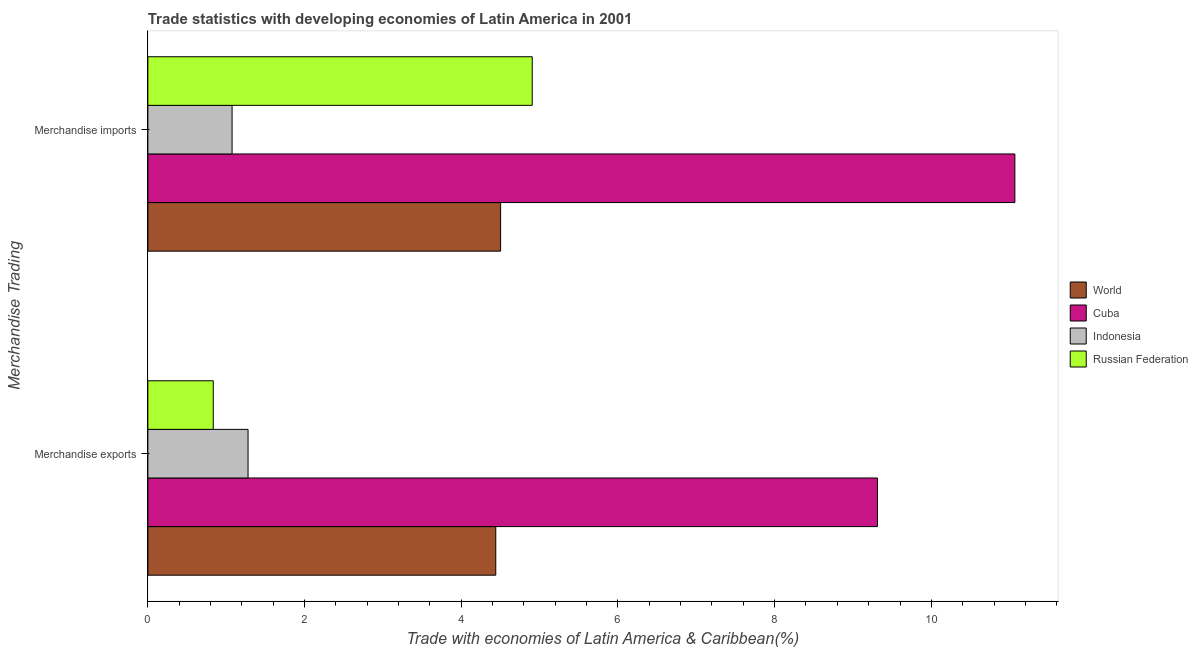How many different coloured bars are there?
Give a very brief answer. 4. How many groups of bars are there?
Offer a very short reply. 2. Are the number of bars on each tick of the Y-axis equal?
Keep it short and to the point. Yes. How many bars are there on the 2nd tick from the top?
Offer a very short reply. 4. What is the label of the 1st group of bars from the top?
Keep it short and to the point. Merchandise imports. What is the merchandise imports in Indonesia?
Keep it short and to the point. 1.07. Across all countries, what is the maximum merchandise exports?
Provide a short and direct response. 9.31. Across all countries, what is the minimum merchandise imports?
Provide a succinct answer. 1.07. In which country was the merchandise imports maximum?
Your answer should be compact. Cuba. In which country was the merchandise exports minimum?
Keep it short and to the point. Russian Federation. What is the total merchandise exports in the graph?
Provide a short and direct response. 15.87. What is the difference between the merchandise exports in World and that in Russian Federation?
Make the answer very short. 3.61. What is the difference between the merchandise exports in World and the merchandise imports in Indonesia?
Your answer should be very brief. 3.37. What is the average merchandise imports per country?
Ensure brevity in your answer.  5.39. What is the difference between the merchandise exports and merchandise imports in Cuba?
Give a very brief answer. -1.75. What is the ratio of the merchandise imports in Russian Federation to that in Cuba?
Your answer should be very brief. 0.44. In how many countries, is the merchandise imports greater than the average merchandise imports taken over all countries?
Keep it short and to the point. 1. What does the 2nd bar from the bottom in Merchandise exports represents?
Your answer should be very brief. Cuba. How many bars are there?
Provide a succinct answer. 8. How many countries are there in the graph?
Make the answer very short. 4. Are the values on the major ticks of X-axis written in scientific E-notation?
Offer a very short reply. No. Does the graph contain grids?
Provide a short and direct response. No. How many legend labels are there?
Make the answer very short. 4. What is the title of the graph?
Provide a succinct answer. Trade statistics with developing economies of Latin America in 2001. Does "Belize" appear as one of the legend labels in the graph?
Provide a succinct answer. No. What is the label or title of the X-axis?
Offer a very short reply. Trade with economies of Latin America & Caribbean(%). What is the label or title of the Y-axis?
Offer a very short reply. Merchandise Trading. What is the Trade with economies of Latin America & Caribbean(%) of World in Merchandise exports?
Keep it short and to the point. 4.44. What is the Trade with economies of Latin America & Caribbean(%) of Cuba in Merchandise exports?
Offer a terse response. 9.31. What is the Trade with economies of Latin America & Caribbean(%) in Indonesia in Merchandise exports?
Your answer should be very brief. 1.28. What is the Trade with economies of Latin America & Caribbean(%) of Russian Federation in Merchandise exports?
Keep it short and to the point. 0.83. What is the Trade with economies of Latin America & Caribbean(%) in World in Merchandise imports?
Provide a succinct answer. 4.5. What is the Trade with economies of Latin America & Caribbean(%) in Cuba in Merchandise imports?
Your response must be concise. 11.07. What is the Trade with economies of Latin America & Caribbean(%) of Indonesia in Merchandise imports?
Offer a terse response. 1.07. What is the Trade with economies of Latin America & Caribbean(%) of Russian Federation in Merchandise imports?
Make the answer very short. 4.91. Across all Merchandise Trading, what is the maximum Trade with economies of Latin America & Caribbean(%) of World?
Make the answer very short. 4.5. Across all Merchandise Trading, what is the maximum Trade with economies of Latin America & Caribbean(%) in Cuba?
Give a very brief answer. 11.07. Across all Merchandise Trading, what is the maximum Trade with economies of Latin America & Caribbean(%) of Indonesia?
Keep it short and to the point. 1.28. Across all Merchandise Trading, what is the maximum Trade with economies of Latin America & Caribbean(%) of Russian Federation?
Offer a terse response. 4.91. Across all Merchandise Trading, what is the minimum Trade with economies of Latin America & Caribbean(%) of World?
Provide a succinct answer. 4.44. Across all Merchandise Trading, what is the minimum Trade with economies of Latin America & Caribbean(%) of Cuba?
Offer a very short reply. 9.31. Across all Merchandise Trading, what is the minimum Trade with economies of Latin America & Caribbean(%) in Indonesia?
Keep it short and to the point. 1.07. Across all Merchandise Trading, what is the minimum Trade with economies of Latin America & Caribbean(%) in Russian Federation?
Offer a very short reply. 0.83. What is the total Trade with economies of Latin America & Caribbean(%) of World in the graph?
Offer a very short reply. 8.94. What is the total Trade with economies of Latin America & Caribbean(%) in Cuba in the graph?
Provide a succinct answer. 20.38. What is the total Trade with economies of Latin America & Caribbean(%) of Indonesia in the graph?
Your answer should be very brief. 2.35. What is the total Trade with economies of Latin America & Caribbean(%) of Russian Federation in the graph?
Provide a succinct answer. 5.74. What is the difference between the Trade with economies of Latin America & Caribbean(%) in World in Merchandise exports and that in Merchandise imports?
Your answer should be very brief. -0.06. What is the difference between the Trade with economies of Latin America & Caribbean(%) of Cuba in Merchandise exports and that in Merchandise imports?
Give a very brief answer. -1.75. What is the difference between the Trade with economies of Latin America & Caribbean(%) in Indonesia in Merchandise exports and that in Merchandise imports?
Your answer should be compact. 0.2. What is the difference between the Trade with economies of Latin America & Caribbean(%) in Russian Federation in Merchandise exports and that in Merchandise imports?
Provide a succinct answer. -4.07. What is the difference between the Trade with economies of Latin America & Caribbean(%) of World in Merchandise exports and the Trade with economies of Latin America & Caribbean(%) of Cuba in Merchandise imports?
Offer a very short reply. -6.63. What is the difference between the Trade with economies of Latin America & Caribbean(%) in World in Merchandise exports and the Trade with economies of Latin America & Caribbean(%) in Indonesia in Merchandise imports?
Provide a short and direct response. 3.37. What is the difference between the Trade with economies of Latin America & Caribbean(%) of World in Merchandise exports and the Trade with economies of Latin America & Caribbean(%) of Russian Federation in Merchandise imports?
Provide a succinct answer. -0.47. What is the difference between the Trade with economies of Latin America & Caribbean(%) of Cuba in Merchandise exports and the Trade with economies of Latin America & Caribbean(%) of Indonesia in Merchandise imports?
Your response must be concise. 8.24. What is the difference between the Trade with economies of Latin America & Caribbean(%) in Cuba in Merchandise exports and the Trade with economies of Latin America & Caribbean(%) in Russian Federation in Merchandise imports?
Offer a very short reply. 4.41. What is the difference between the Trade with economies of Latin America & Caribbean(%) in Indonesia in Merchandise exports and the Trade with economies of Latin America & Caribbean(%) in Russian Federation in Merchandise imports?
Keep it short and to the point. -3.63. What is the average Trade with economies of Latin America & Caribbean(%) in World per Merchandise Trading?
Provide a succinct answer. 4.47. What is the average Trade with economies of Latin America & Caribbean(%) in Cuba per Merchandise Trading?
Your answer should be compact. 10.19. What is the average Trade with economies of Latin America & Caribbean(%) in Indonesia per Merchandise Trading?
Your response must be concise. 1.18. What is the average Trade with economies of Latin America & Caribbean(%) in Russian Federation per Merchandise Trading?
Offer a very short reply. 2.87. What is the difference between the Trade with economies of Latin America & Caribbean(%) of World and Trade with economies of Latin America & Caribbean(%) of Cuba in Merchandise exports?
Your response must be concise. -4.87. What is the difference between the Trade with economies of Latin America & Caribbean(%) of World and Trade with economies of Latin America & Caribbean(%) of Indonesia in Merchandise exports?
Your response must be concise. 3.16. What is the difference between the Trade with economies of Latin America & Caribbean(%) of World and Trade with economies of Latin America & Caribbean(%) of Russian Federation in Merchandise exports?
Provide a short and direct response. 3.61. What is the difference between the Trade with economies of Latin America & Caribbean(%) in Cuba and Trade with economies of Latin America & Caribbean(%) in Indonesia in Merchandise exports?
Your answer should be compact. 8.03. What is the difference between the Trade with economies of Latin America & Caribbean(%) of Cuba and Trade with economies of Latin America & Caribbean(%) of Russian Federation in Merchandise exports?
Ensure brevity in your answer.  8.48. What is the difference between the Trade with economies of Latin America & Caribbean(%) of Indonesia and Trade with economies of Latin America & Caribbean(%) of Russian Federation in Merchandise exports?
Offer a terse response. 0.44. What is the difference between the Trade with economies of Latin America & Caribbean(%) of World and Trade with economies of Latin America & Caribbean(%) of Cuba in Merchandise imports?
Make the answer very short. -6.56. What is the difference between the Trade with economies of Latin America & Caribbean(%) of World and Trade with economies of Latin America & Caribbean(%) of Indonesia in Merchandise imports?
Offer a terse response. 3.43. What is the difference between the Trade with economies of Latin America & Caribbean(%) of World and Trade with economies of Latin America & Caribbean(%) of Russian Federation in Merchandise imports?
Offer a very short reply. -0.4. What is the difference between the Trade with economies of Latin America & Caribbean(%) in Cuba and Trade with economies of Latin America & Caribbean(%) in Indonesia in Merchandise imports?
Provide a succinct answer. 9.99. What is the difference between the Trade with economies of Latin America & Caribbean(%) in Cuba and Trade with economies of Latin America & Caribbean(%) in Russian Federation in Merchandise imports?
Your answer should be compact. 6.16. What is the difference between the Trade with economies of Latin America & Caribbean(%) of Indonesia and Trade with economies of Latin America & Caribbean(%) of Russian Federation in Merchandise imports?
Offer a very short reply. -3.83. What is the ratio of the Trade with economies of Latin America & Caribbean(%) in World in Merchandise exports to that in Merchandise imports?
Offer a very short reply. 0.99. What is the ratio of the Trade with economies of Latin America & Caribbean(%) in Cuba in Merchandise exports to that in Merchandise imports?
Your answer should be compact. 0.84. What is the ratio of the Trade with economies of Latin America & Caribbean(%) in Indonesia in Merchandise exports to that in Merchandise imports?
Offer a terse response. 1.19. What is the ratio of the Trade with economies of Latin America & Caribbean(%) of Russian Federation in Merchandise exports to that in Merchandise imports?
Offer a very short reply. 0.17. What is the difference between the highest and the second highest Trade with economies of Latin America & Caribbean(%) in World?
Your response must be concise. 0.06. What is the difference between the highest and the second highest Trade with economies of Latin America & Caribbean(%) in Cuba?
Your response must be concise. 1.75. What is the difference between the highest and the second highest Trade with economies of Latin America & Caribbean(%) in Indonesia?
Your answer should be very brief. 0.2. What is the difference between the highest and the second highest Trade with economies of Latin America & Caribbean(%) in Russian Federation?
Provide a short and direct response. 4.07. What is the difference between the highest and the lowest Trade with economies of Latin America & Caribbean(%) of World?
Ensure brevity in your answer.  0.06. What is the difference between the highest and the lowest Trade with economies of Latin America & Caribbean(%) in Cuba?
Your answer should be compact. 1.75. What is the difference between the highest and the lowest Trade with economies of Latin America & Caribbean(%) of Indonesia?
Provide a succinct answer. 0.2. What is the difference between the highest and the lowest Trade with economies of Latin America & Caribbean(%) of Russian Federation?
Your answer should be very brief. 4.07. 